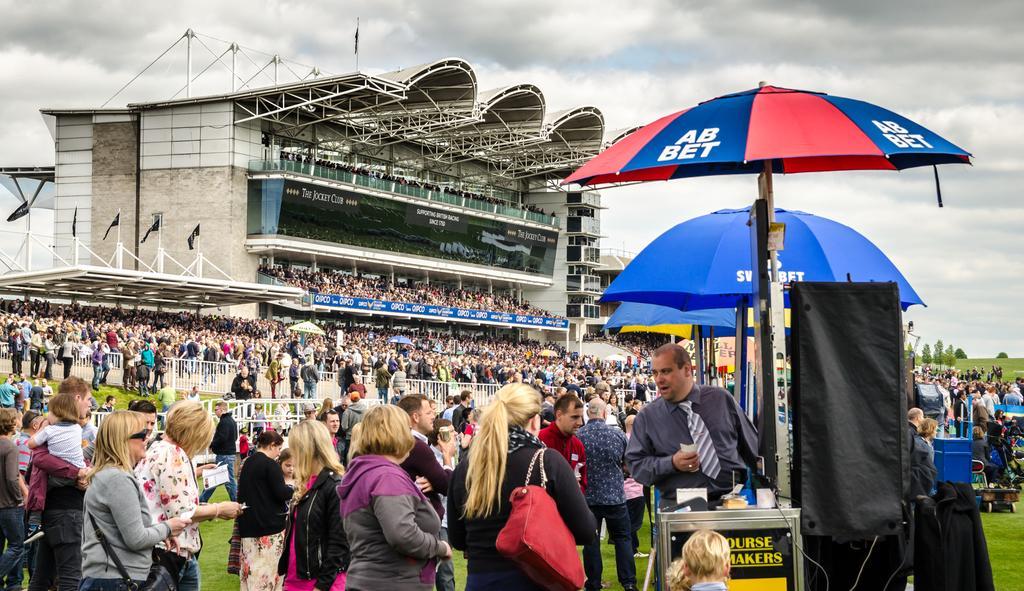Please provide a concise description of this image. At the top of the image we can see sky with clouds, iron grill, building, advertisement, flags, flag posts, spectators and iron bars. At the bottom of the image we can see parasols, crowd, ground and trees. 